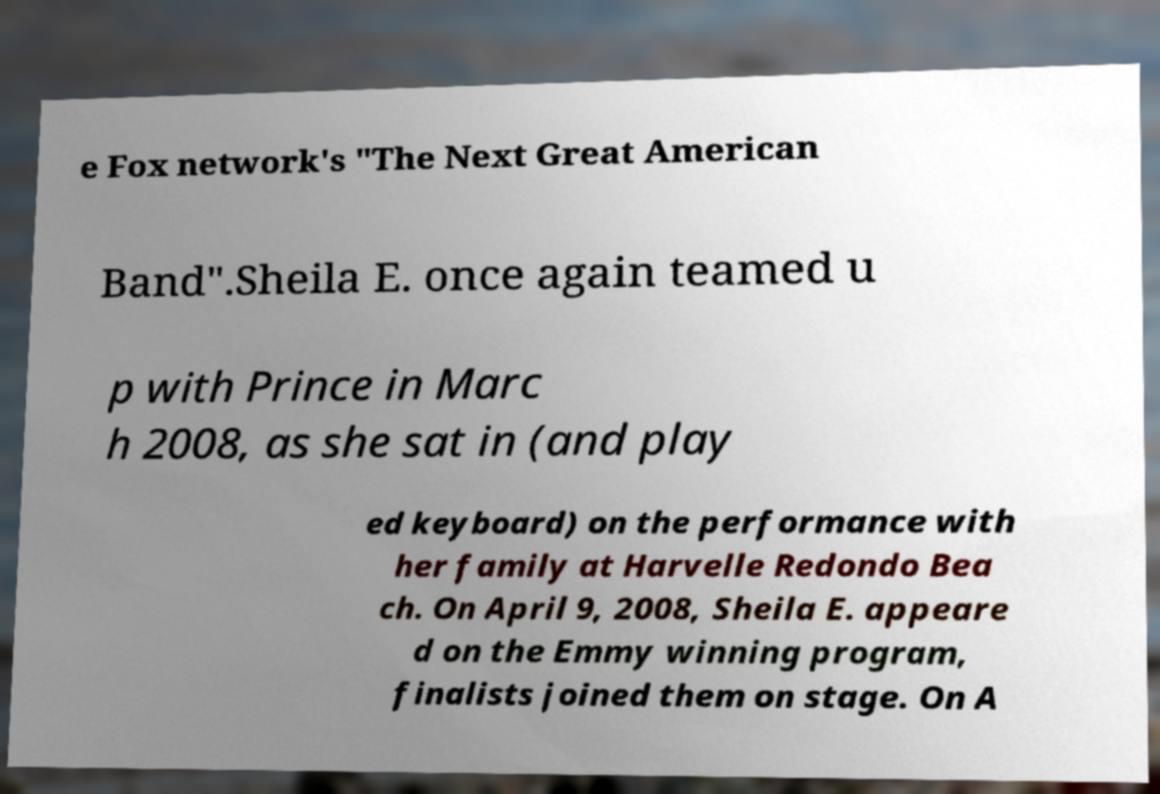For documentation purposes, I need the text within this image transcribed. Could you provide that? e Fox network's "The Next Great American Band".Sheila E. once again teamed u p with Prince in Marc h 2008, as she sat in (and play ed keyboard) on the performance with her family at Harvelle Redondo Bea ch. On April 9, 2008, Sheila E. appeare d on the Emmy winning program, finalists joined them on stage. On A 